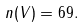Convert formula to latex. <formula><loc_0><loc_0><loc_500><loc_500>n ( V ) = 6 9 .</formula> 